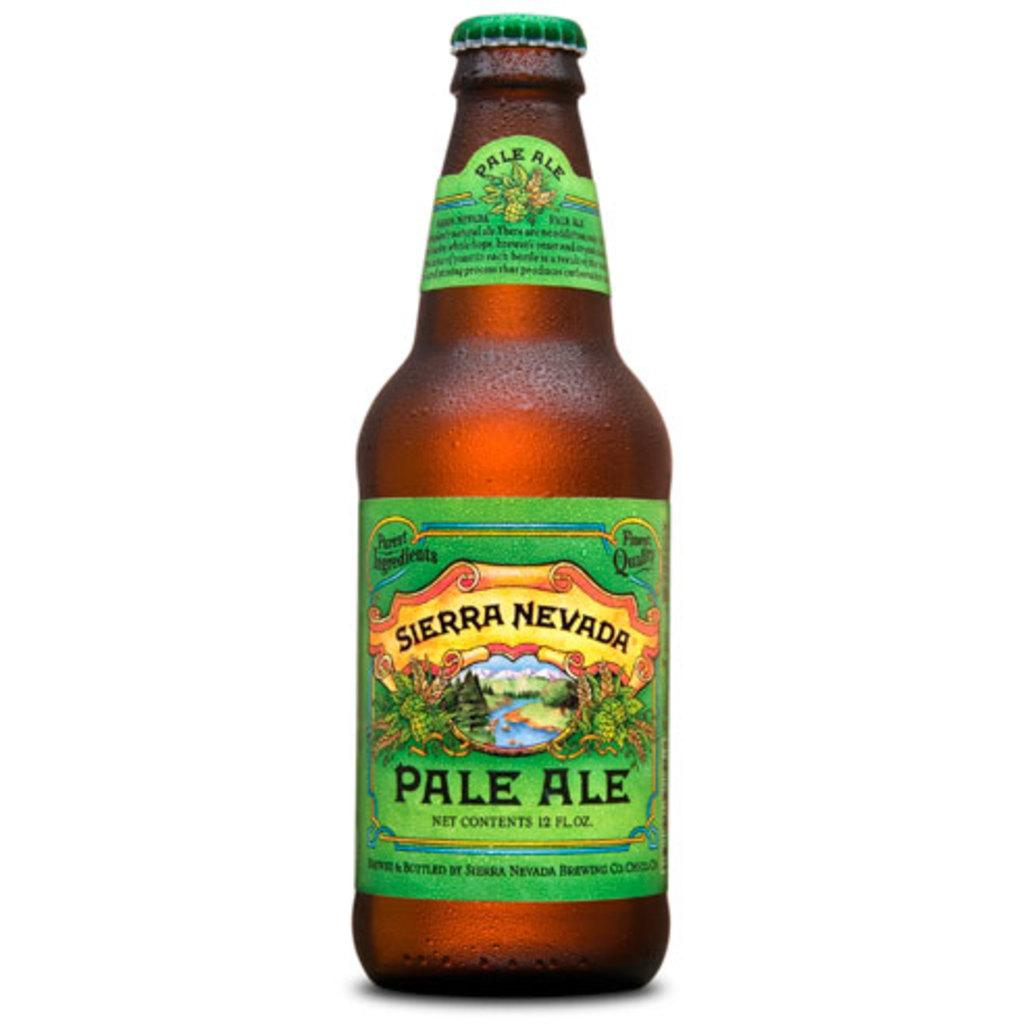<image>
Share a concise interpretation of the image provided. An unopened bottle of Sierra Nevada Pale Ale has a bright green label, with an image of a river flowing through a valley. 